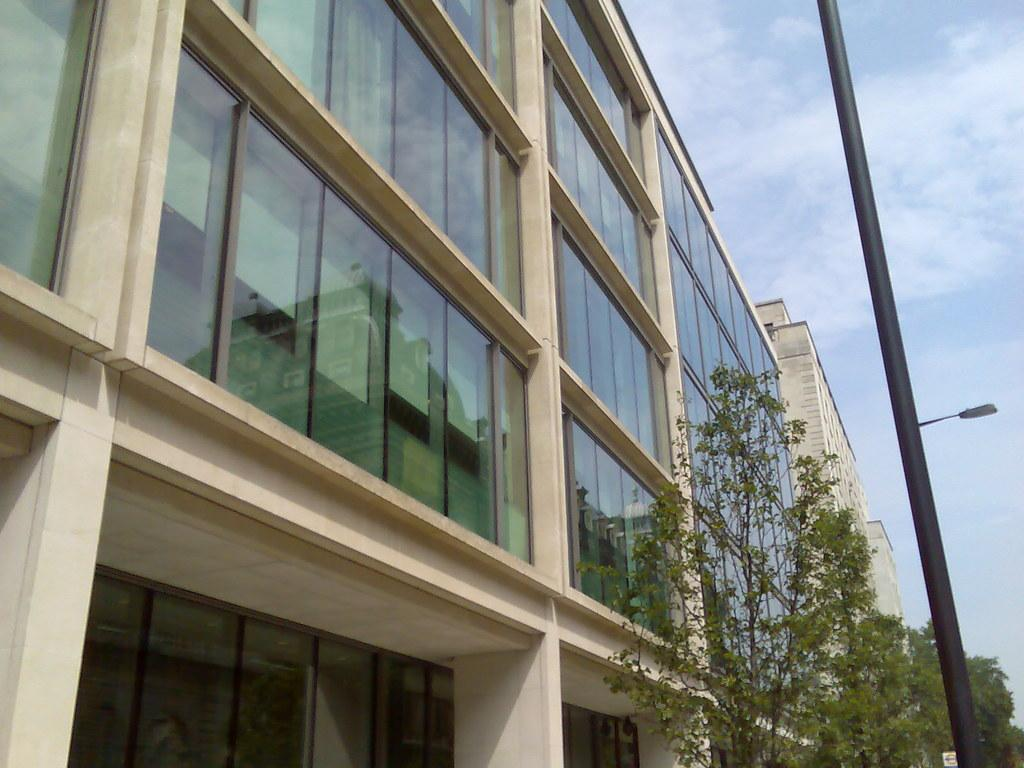What type of structure is in the image? There is a building in the image. Can you describe the color of the building? The building is cream-colored. What other natural elements can be seen in the image? There are trees in the image. What is the color of the trees? The trees are green. What type of entrance is visible in the image? There are glass doors in the image. What is the color of the sky in the image? The sky is blue and white. What type of memory is stored in the building in the image? There is no information about any memory being stored in the building in the image. 